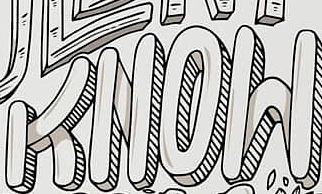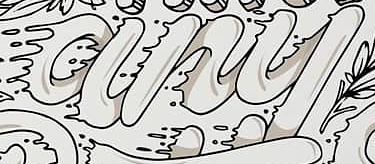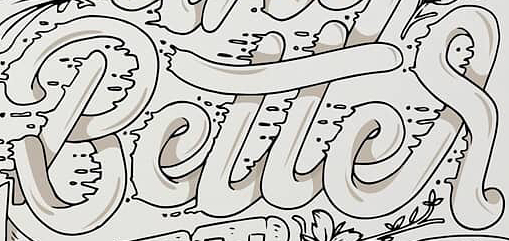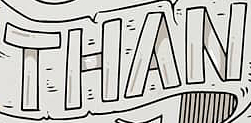Read the text content from these images in order, separated by a semicolon. KNOW; any; Better; THAN 